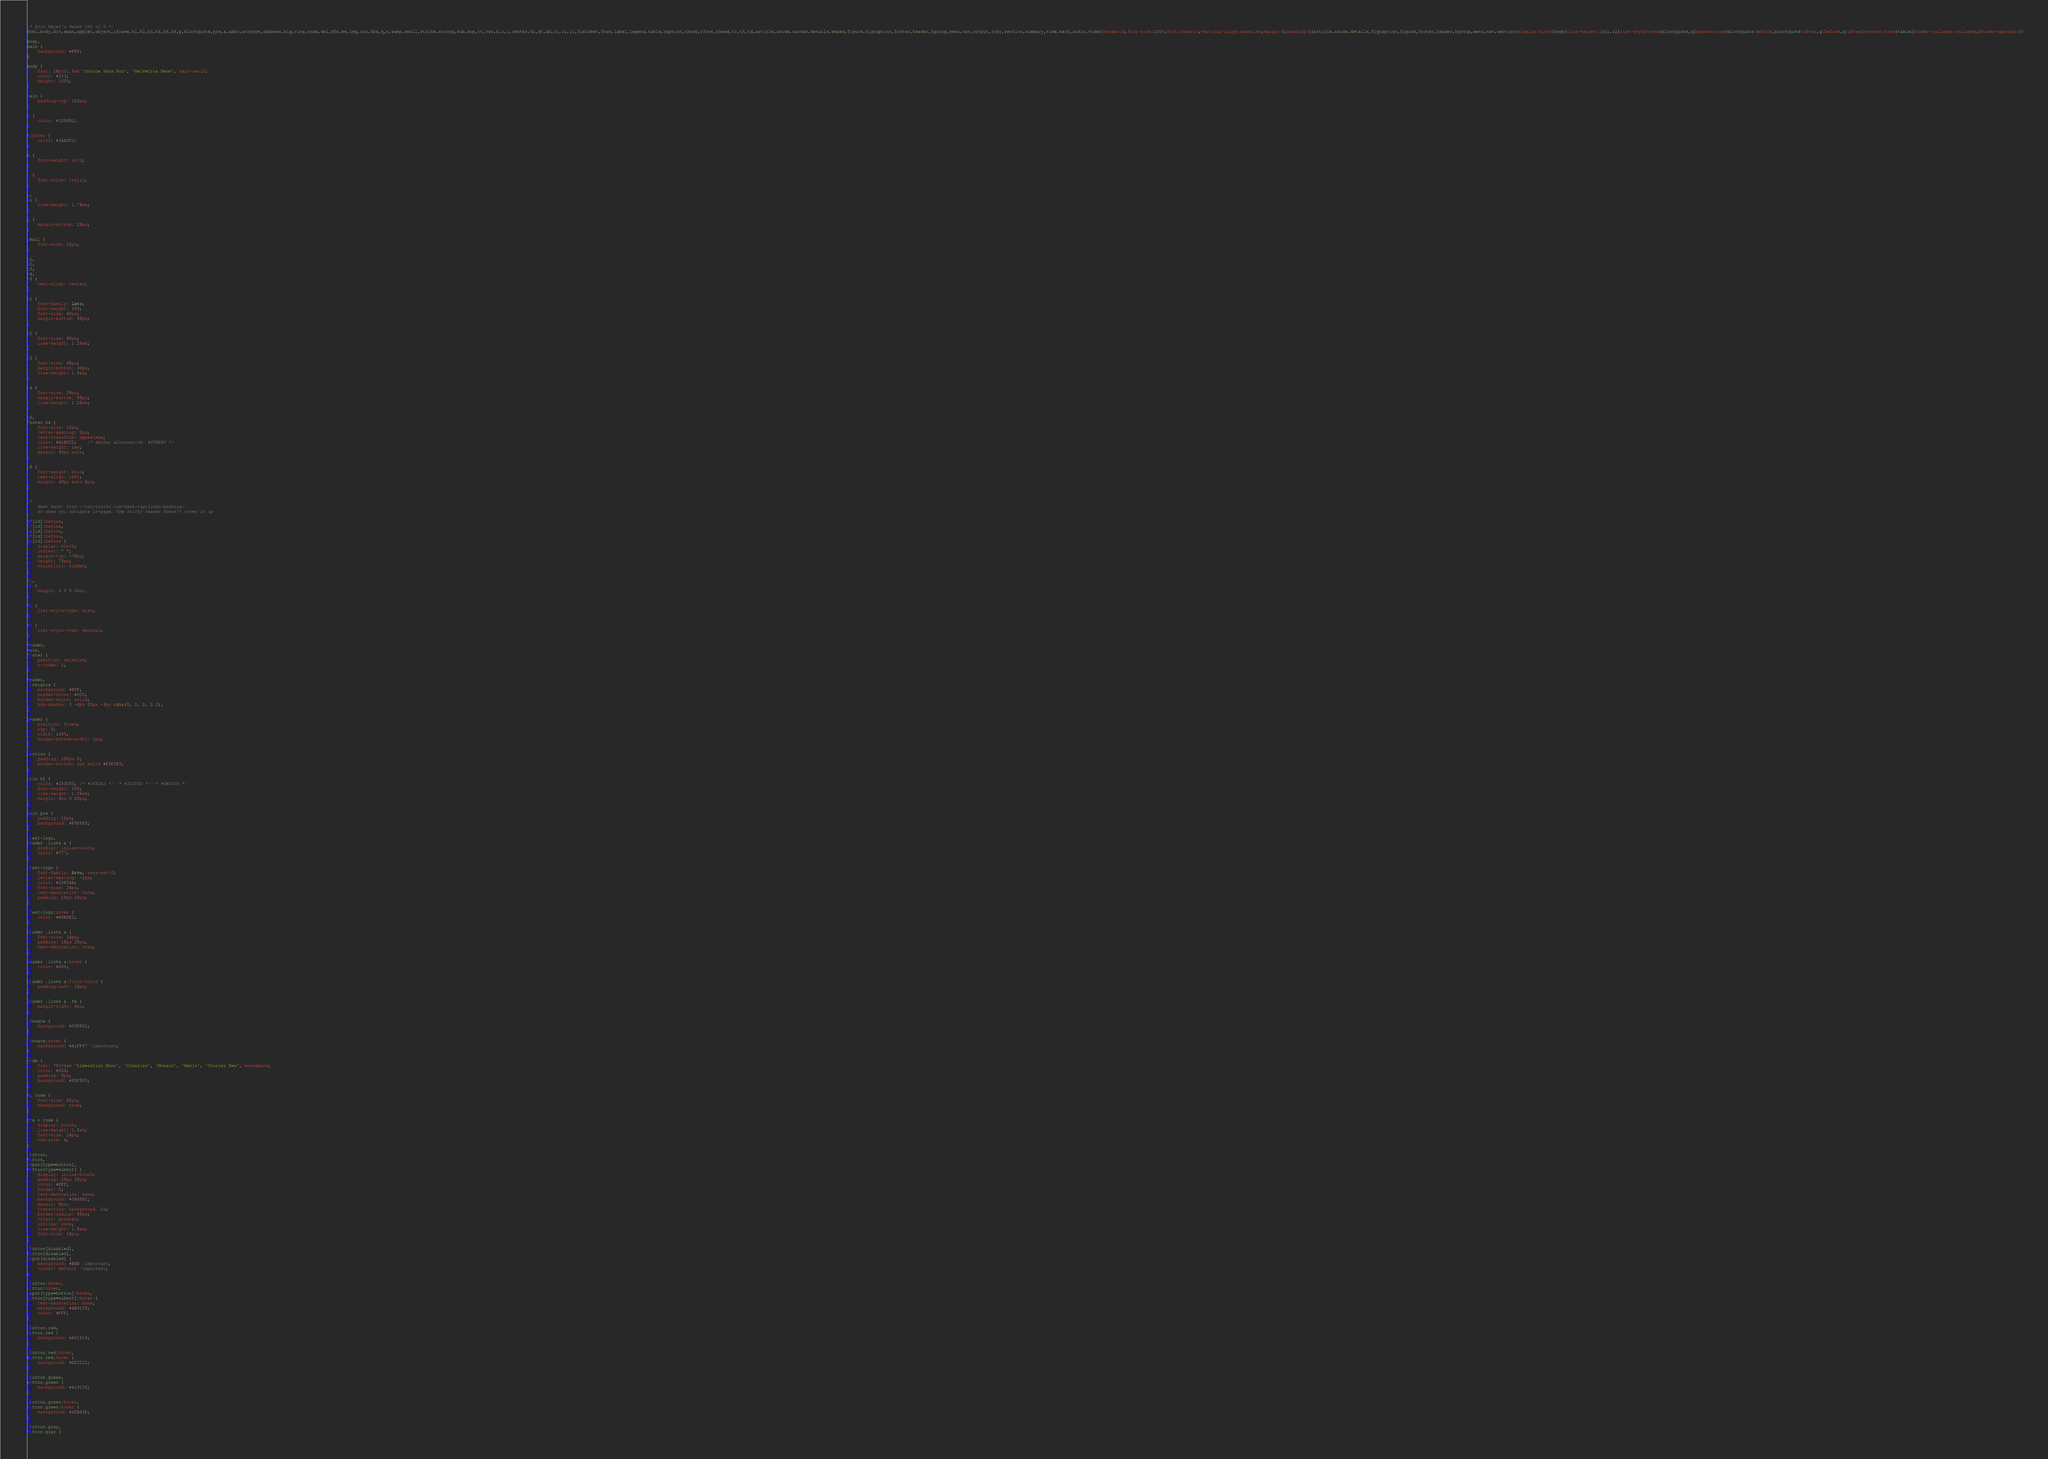Convert code to text. <code><loc_0><loc_0><loc_500><loc_500><_CSS_>/* Eric Meyer's Reset CSS v2.0 */
html,body,div,span,applet,object,iframe,h1,h2,h3,h4,h5,h6,p,blockquote,pre,a,abbr,acronym,address,big,cite,code,del,dfn,em,img,ins,kbd,q,s,samp,small,strike,strong,sub,sup,tt,var,b,u,i,center,dl,dt,dd,ol,ul,li,fieldset,form,label,legend,table,caption,tbody,tfoot,thead,tr,th,td,article,aside,canvas,details,embed,figure,figcaption,footer,header,hgroup,menu,nav,output,ruby,section,summary,time,mark,audio,video{border:0;font-size:100%;font:inherit;vertical-align:baseline;margin:0;padding:0}article,aside,details,figcaption,figure,footer,header,hgroup,menu,nav,section{display:block}body{line-height:1}ol,ul{list-style:none}blockquote,q{quotes:none}blockquote:before,blockquote:after,q:before,q:after{content:none}table{border-collapse:collapse;border-spacing:0}

body,
main {
	background: #FFF;
}

body {
	font: 18px/1.5em 'Source Sans Pro', 'Helvetica Neue', sans-serif;
	color: #333;
	height: 100%;
}

main {
	padding-top: 100px;
}

a {
	color: #1D58B1;
}

a:hover {
	color: #2AACFC;
}

b {
	font-weight: bold;
}

i {
	font-style: italic;
}

p,
li {
	line-height: 1.75em;
}

p {
	margin-bottom: 25px;
}

small {
	font-size: 12px;
}

h1,
h2,
h3,
h4,
h5 {
	text-align: center;
}

h1 {
	font-family: Lato;
	font-weight: 300;
	font-size: 40px;
	margin-bottom: 50px;
}

h2 {
	font-size: 60px;
	line-height: 1.25em;
}

h3 {
	font-size: 48px;
	margin-bottom: 30px;
	line-height: 1.5em;
}

h4 {
	font-size: 28px;
	margin-bottom: 50px;
	line-height: 1.25em;
}

h5,
footer h4 {
	font-size: 12px;
	letter-spacing: 2px;
	text-transform: uppercase;
	color: #A1B2C2;	/* darker alternative: #698EB0 */
	line-height: 1em;
	margin: 50px auto;
}

h6 {
	font-weight: bold;
	text-align: left;
	margin: 40px auto 5px;
}


/*
	Neat hack! http://css-tricks.com/hash-tag-links-padding/
	So when you navigate in-page, the sticky header doesn't cover it up
*/
h2[id]:before,
h3[id]:before,
h4[id]:before,
h5[id]:before,
h6[id]:before { 
	display: block;
	content: " ";
	margin-top: -75px;
	height: 75px;
	visibility: hidden;
}

ul,
ol {
	margin: 0 0 0 2em;
}

ul {
	list-style-type: disc;
}

ol {
	list-style-type: decimal;
}

header,
main,
footer {
	position: relative;
	z-index: 1;
}

header,
.insignia {
	background: #FFF;
	border-color: #CCC;
	border-style: solid;
	box-shadow: 0 -4px 20px -3px rgba(0, 0, 0, 0.2);
}

header {
	position: fixed;
	top: 0;
	width: 100%;
	border-bottom-width: 1px;
}

section {
	padding: 100px 0;
	border-bottom: 1px solid #E3E3E3;
}

main h2 {
	color: #253C50; /* #365DA3 */ /* #3D3D3D */ /* #9B0000 */
	font-weight: 300;
	line-height: 1.25em;
	margin: 0px 0 50px;
}

main pre {
	padding: 10px;
	background: #F5F5F5;
}

.text-logo,
header .links a {
	display: inline-block;
	color: #777;
}

.text-logo {
	font-family: Arvo, sans-serif;
	letter-spacing: -1px;
	color: #1D80AB;
	font-size: 24px;
	text-decoration: none;
	padding: 15px 10px;
}

.text-logo:hover {
	color: #66B0E2;
}

header .links a {
	font-size: 14px;
	padding: 15px 25px;
	text-decoration: none;
}

header .links a:hover {
	color: #000;
}

header .links a:first-child {
	padding-left: 10px;
}

header .links a .fa {
	margin-right: 5px;
}

.donate {
	background: #D9FFD1;
}

.donate:hover {
	background: #A1FF87 !important;
}

code {
	font: 75%/1em 'Liberation Mono', 'Consolas', 'Monaco', 'Menlo', 'Courier New', monospace;
	color: #000;
	padding: 5px;
	background: #F5F5F5;
}

h2 code {
	font-size: 42px;
	background: none;
}

pre > code {
	display: block;
	line-height: 1.5em;
	font-size: 14px;
	tab-size: 4;
}

.button,
button,
input[type=button],
button[type=submit] {
	display: inline-block;
	padding: 10px 25px;
	color: #FFF;
	border: 0;
	text-decoration: none;
	background: #366992;
	margin: 5px;
	transition: background .2s;
	border-radius: 50px;
	cursor: pointer;
	outline: none;
	line-height: 1.5em;
	font-size: 18px;
}

.button[disabled],
button[disabled],
input[disabled] {
	background: #BBB !important;
	cursor: default !important;
}

.button:hover,
button:hover,
input[type=button]:hover,
button[type=submit]:hover {
	text-decoration: none;
	background: #4B91C9;
	color: #FFF;
}

.button.red,
button.red {
	background: #A01919;
}

.button.red:hover,
button.red:hover {
	background: #DD2222;
}

.button.green,
button.green {
	background: #419236;
}

.button.green:hover,
button.green:hover {
	background: #4DB43F;
}

.button.gray,
button.gray {</code> 